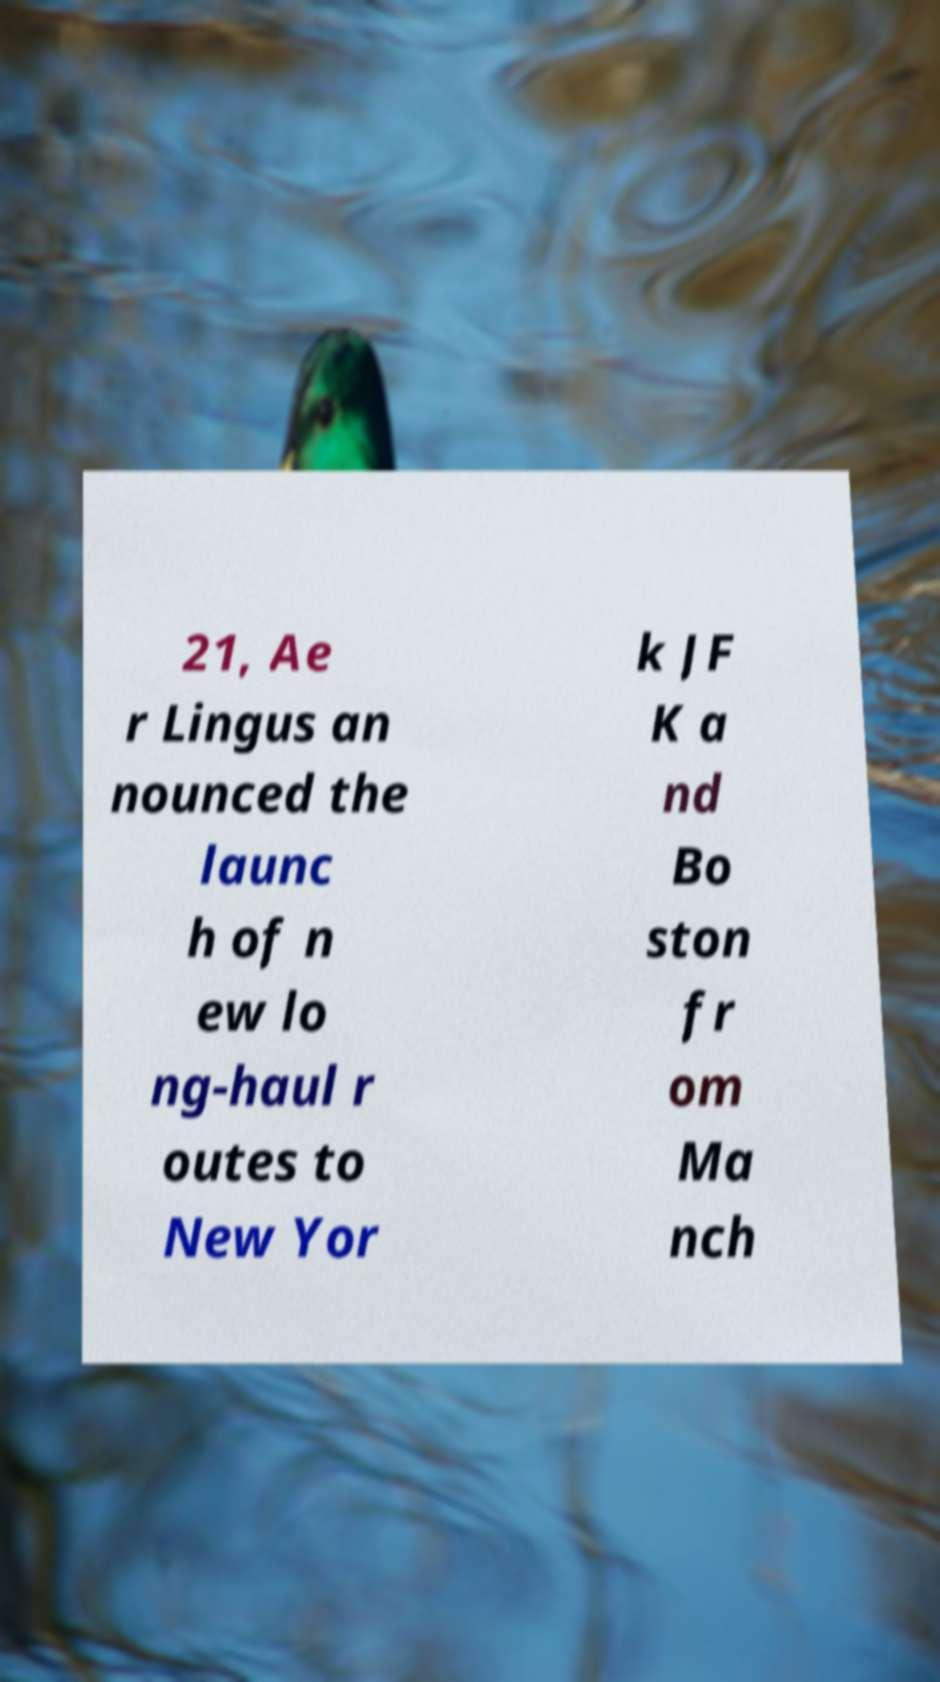Please identify and transcribe the text found in this image. 21, Ae r Lingus an nounced the launc h of n ew lo ng-haul r outes to New Yor k JF K a nd Bo ston fr om Ma nch 